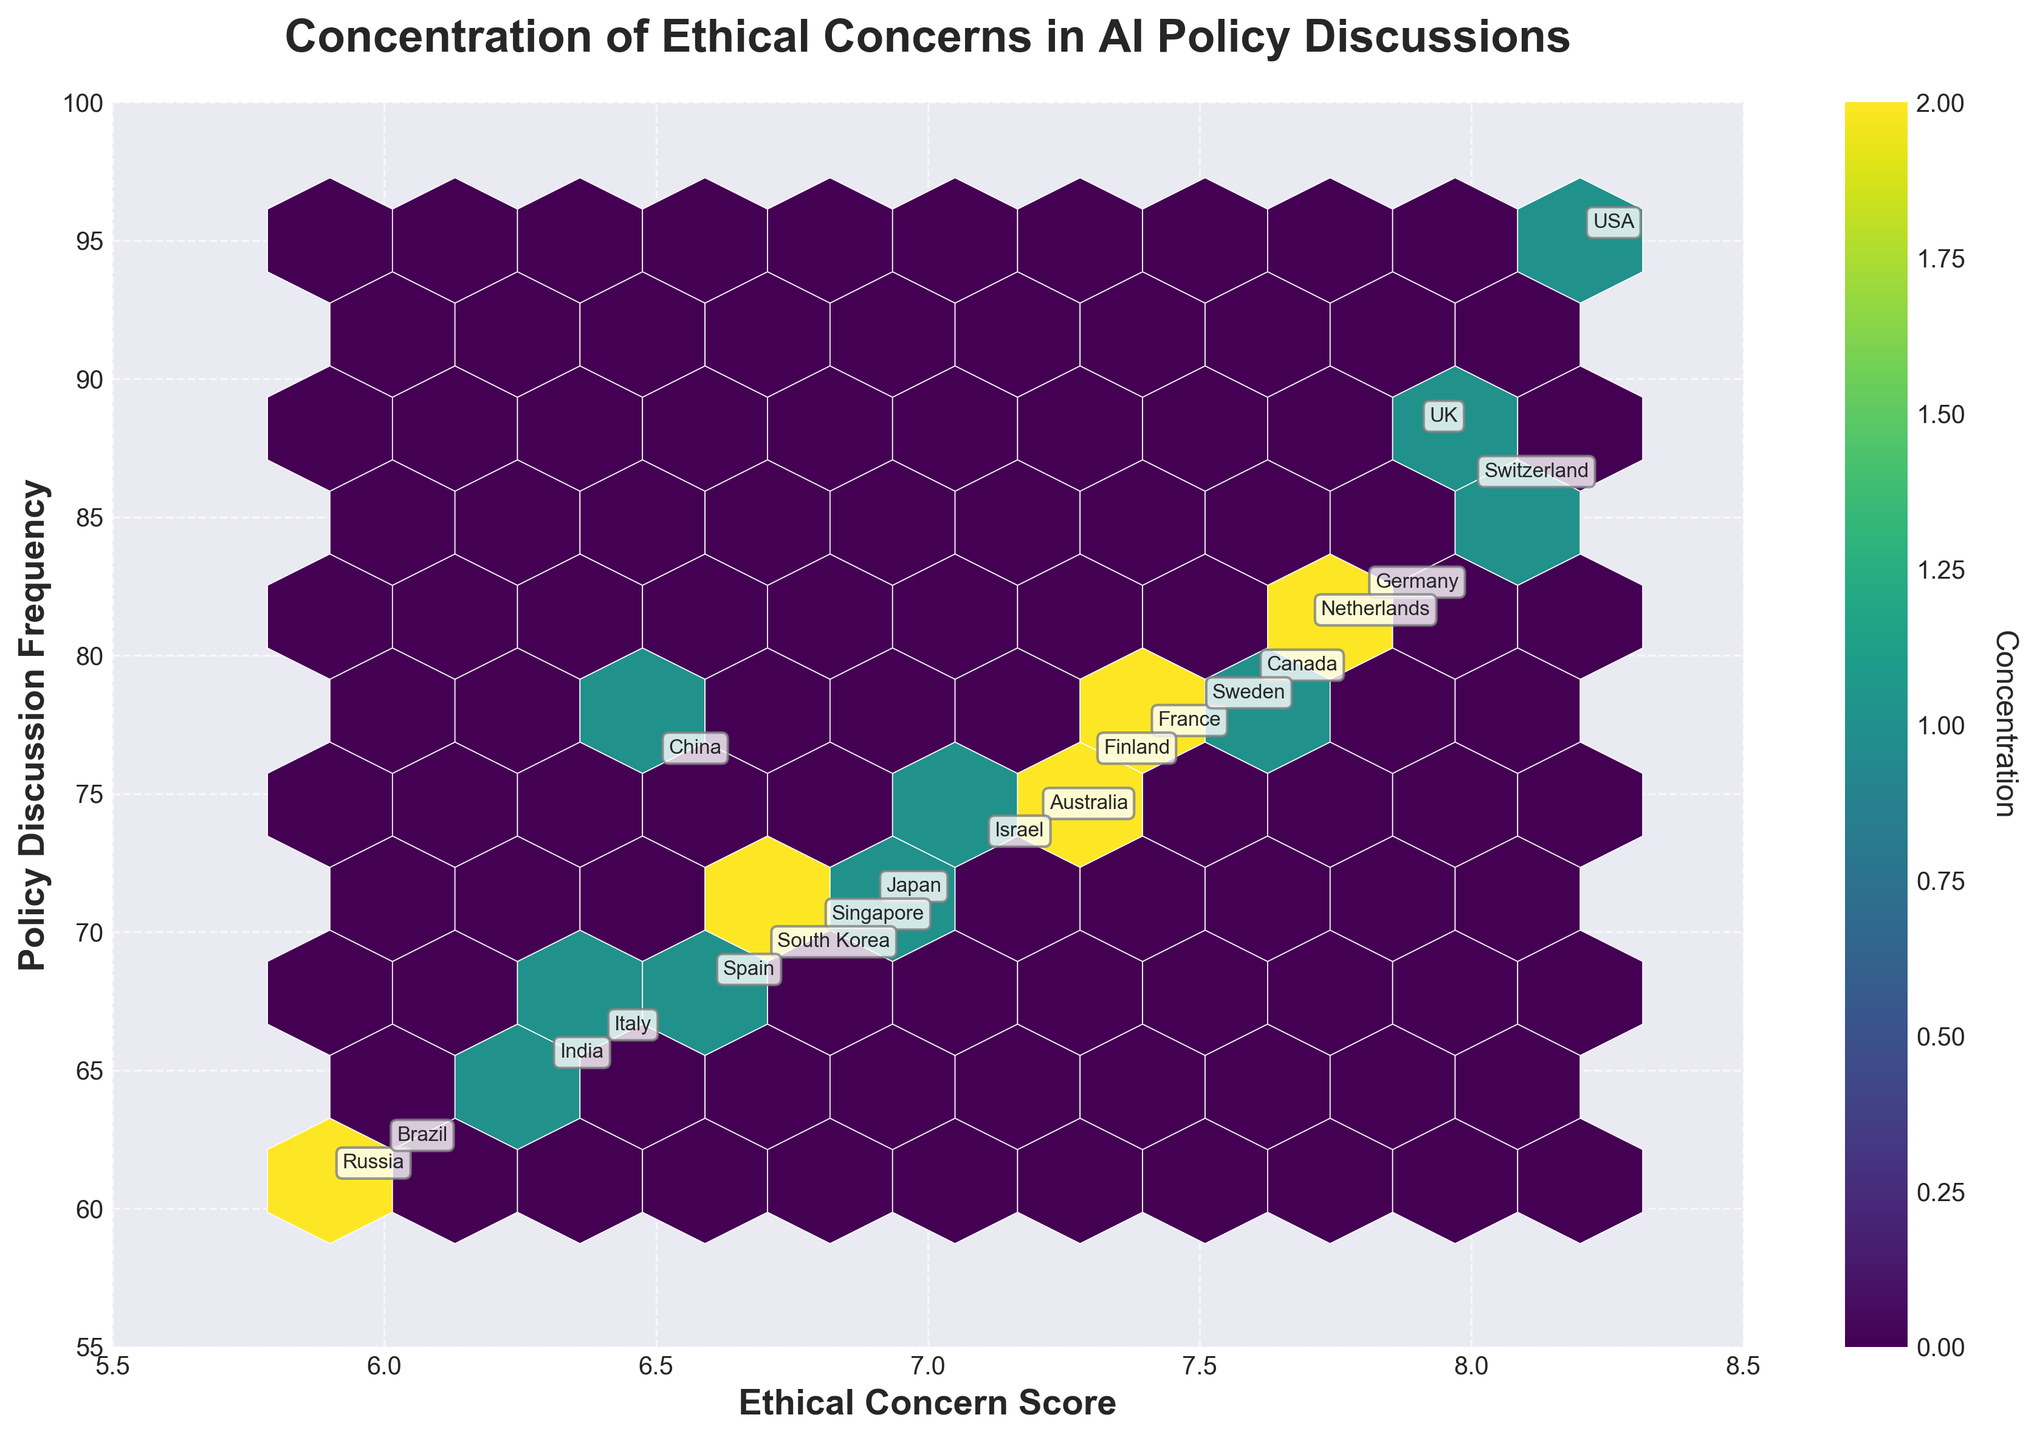How many countries and institutions are represented in the plot? To determine the number of countries and institutions, count each unique entry in the provided data. There are 20 unique entries for both columns.
Answer: 20 Which country has the highest Ethical Concern Score in the plot? Scan the annotations to identify the highest Ethical Concern Score. The highest score is 8.2, which belongs to the USA.
Answer: USA Is there a visible trend between Ethical Concern Score and Policy Discussion Frequency? Look at the overall pattern of the hexagons in the plot. The trend appears to be positive, as higher Ethical Concern Scores generally correspond to higher Policy Discussion Frequencies.
Answer: Yes, a positive trend How does the Policy Discussion Frequency of Japan compare to that of Australia? Find the annotations for Japan and Australia and compare the Policy Discussion Frequencies. Japan has a Policy Discussion Frequency of 71, while Australia has 74.
Answer: Australia is higher What is the difference in Ethical Concern Scores between the highest and lowest scoring countries? Find the highest Ethical Concern Score (8.2, USA) and the lowest (5.9, Russia) and calculate the difference: 8.2 - 5.9 = 2.3.
Answer: 2.3 Are there any clusters of countries with similar Ethical Concern Scores and Policy Discussion Frequencies? Look at the concentrations of hexagons; clusters appear around certain Ethical Concern Scores (7.0 to 7.8) and Policy Discussion Frequencies (70 to 80).
Answer: Yes Which country falls in the middle of the Ethical Concern Score range? Order the Ethical Concern Scores to find the median position. With 20 entries, the median is the average of the 10th and 11th values. Both values are 6.9, corresponding to Japan.
Answer: Japan What is the Ethical Concern Score of the institution with the lowest Policy Discussion Frequency? The annotation with the lowest Policy Discussion Frequency is for the Skolkovo Institute, with a Policy Discussion Frequency of 61. The Ethical Concern Score is 5.9.
Answer: 5.9 Identify the hexagonal grid cell with the highest concentration. Which countries are included in this cell? Look at the color scale and identify the darkest hexagonal grid cell. Find the countries whose scores fall in the range of this cell. The cell includes countries like Sweden, Finland, and the Netherlands (concentrations around 7.6 Ethical Concern Score and 77 - 81 Policy Discussion Frequency).
Answer: Sweden, Finland, Netherlands 